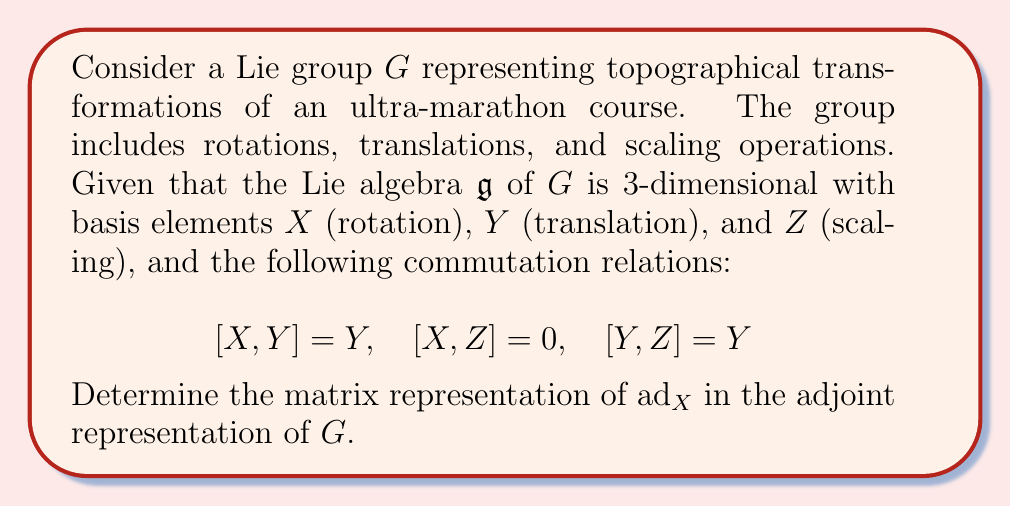Help me with this question. To solve this problem, we need to follow these steps:

1) Recall that for a Lie algebra element $A$, the adjoint representation $\text{ad}_A$ is defined by its action on other elements $B$ as:

   $$\text{ad}_A(B) = [A,B]$$

2) We need to find how $\text{ad}_X$ acts on each basis element $X$, $Y$, and $Z$:

   $$\text{ad}_X(X) = [X,X] = 0$$
   $$\text{ad}_X(Y) = [X,Y] = Y$$
   $$\text{ad}_X(Z) = [X,Z] = 0$$

3) Now, we can represent these actions as a matrix. The columns of the matrix will represent the coefficients of the result when $\text{ad}_X$ acts on each basis element:

   - $\text{ad}_X(X) = 0 = 0X + 0Y + 0Z$
   - $\text{ad}_X(Y) = Y = 0X + 1Y + 0Z$
   - $\text{ad}_X(Z) = 0 = 0X + 0Y + 0Z$

4) Therefore, the matrix representation of $\text{ad}_X$ is:

   $$\text{ad}_X = \begin{pmatrix}
   0 & 0 & 0 \\
   0 & 1 & 0 \\
   0 & 0 & 0
   \end{pmatrix}$$

This matrix represents how rotations (X) affect other transformations in the adjoint representation. It shows that rotations commute with themselves and scaling operations, but have a non-trivial effect on translations.
Answer: $$\text{ad}_X = \begin{pmatrix}
0 & 0 & 0 \\
0 & 1 & 0 \\
0 & 0 & 0
\end{pmatrix}$$ 